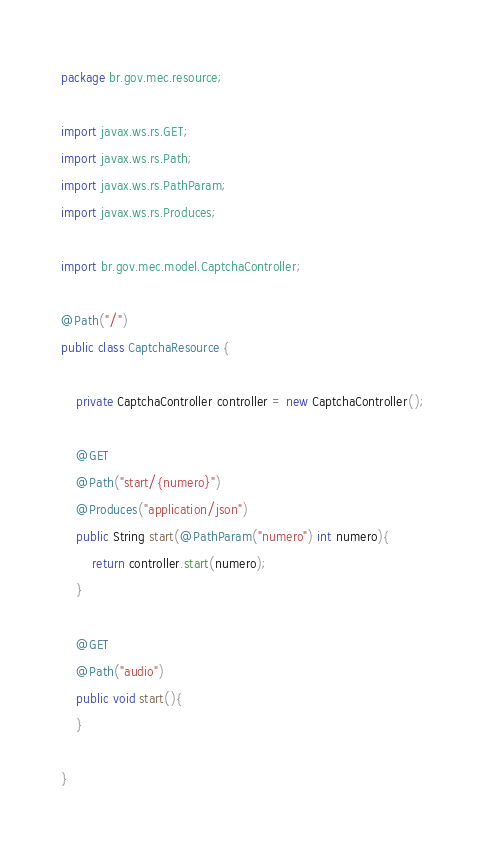<code> <loc_0><loc_0><loc_500><loc_500><_Java_>package br.gov.mec.resource;

import javax.ws.rs.GET;
import javax.ws.rs.Path;
import javax.ws.rs.PathParam;
import javax.ws.rs.Produces;

import br.gov.mec.model.CaptchaController;

@Path("/")
public class CaptchaResource {
	
	private CaptchaController controller = new CaptchaController();

    @GET
    @Path("start/{numero}")
    @Produces("application/json")
    public String start(@PathParam("numero") int numero){
    	return controller.start(numero);
    }
    
    @GET
    @Path("audio")
    public void start(){
    }
    
}</code> 